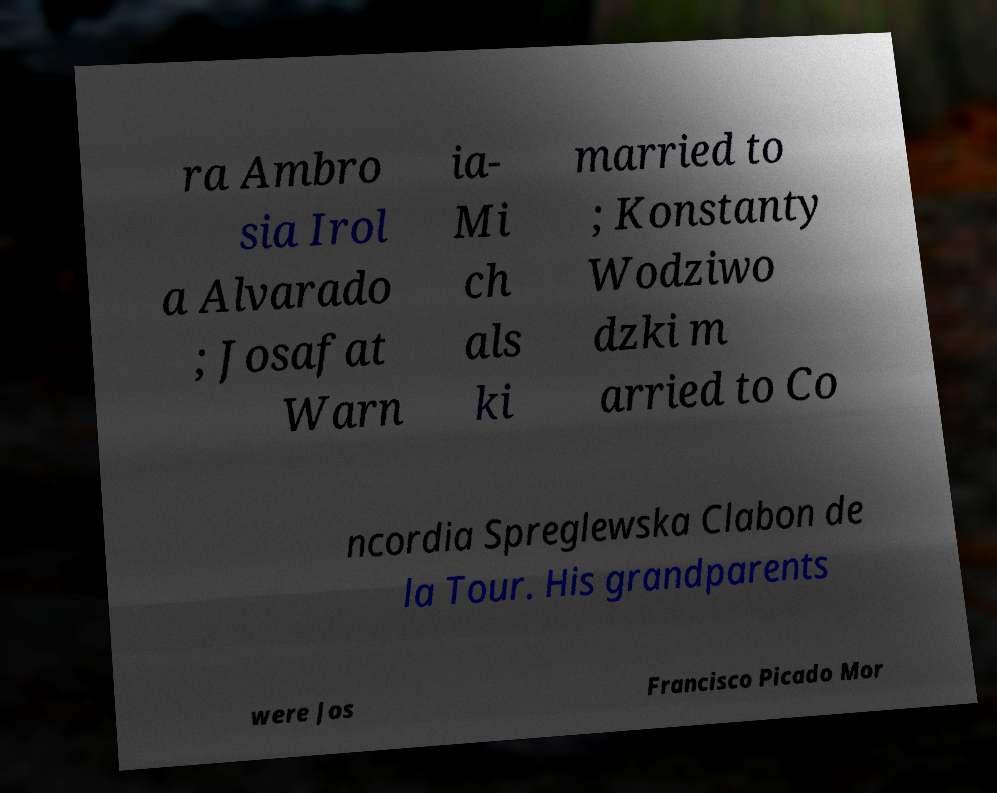Please read and relay the text visible in this image. What does it say? ra Ambro sia Irol a Alvarado ; Josafat Warn ia- Mi ch als ki married to ; Konstanty Wodziwo dzki m arried to Co ncordia Spreglewska Clabon de la Tour. His grandparents were Jos Francisco Picado Mor 